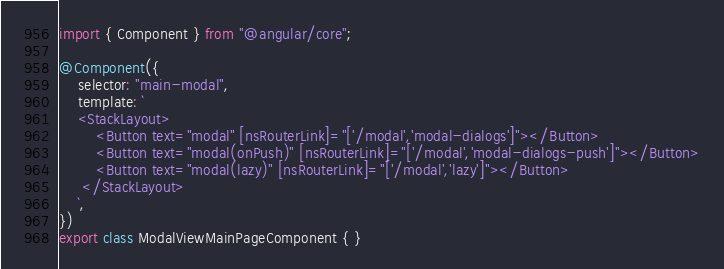Convert code to text. <code><loc_0><loc_0><loc_500><loc_500><_TypeScript_>import { Component } from "@angular/core";

@Component({
    selector: "main-modal",
    template: `
    <StackLayout>
        <Button text="modal" [nsRouterLink]="['/modal','modal-dialogs']"></Button>
        <Button text="modal(onPush)" [nsRouterLink]="['/modal','modal-dialogs-push']"></Button>
        <Button text="modal(lazy)" [nsRouterLink]="['/modal','lazy']"></Button>
     </StackLayout>
    `,
})
export class ModalViewMainPageComponent { }
</code> 